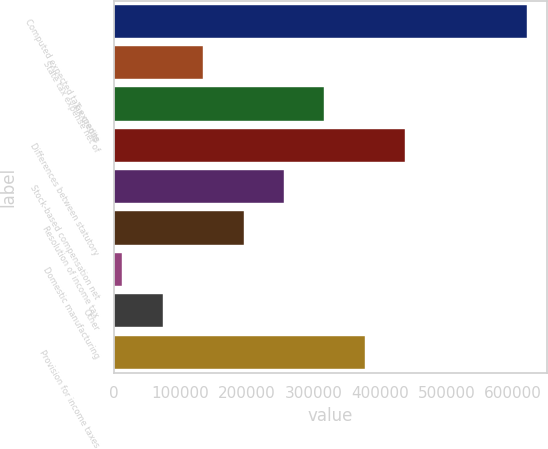Convert chart. <chart><loc_0><loc_0><loc_500><loc_500><bar_chart><fcel>Computed expected tax expense<fcel>State tax expense net of<fcel>Tax credits<fcel>Differences between statutory<fcel>Stock-based compensation net<fcel>Resolution of income tax<fcel>Domestic manufacturing<fcel>Other<fcel>Provision for income taxes<nl><fcel>620240<fcel>134526<fcel>316669<fcel>438097<fcel>255955<fcel>195241<fcel>13098<fcel>73812.2<fcel>377383<nl></chart> 